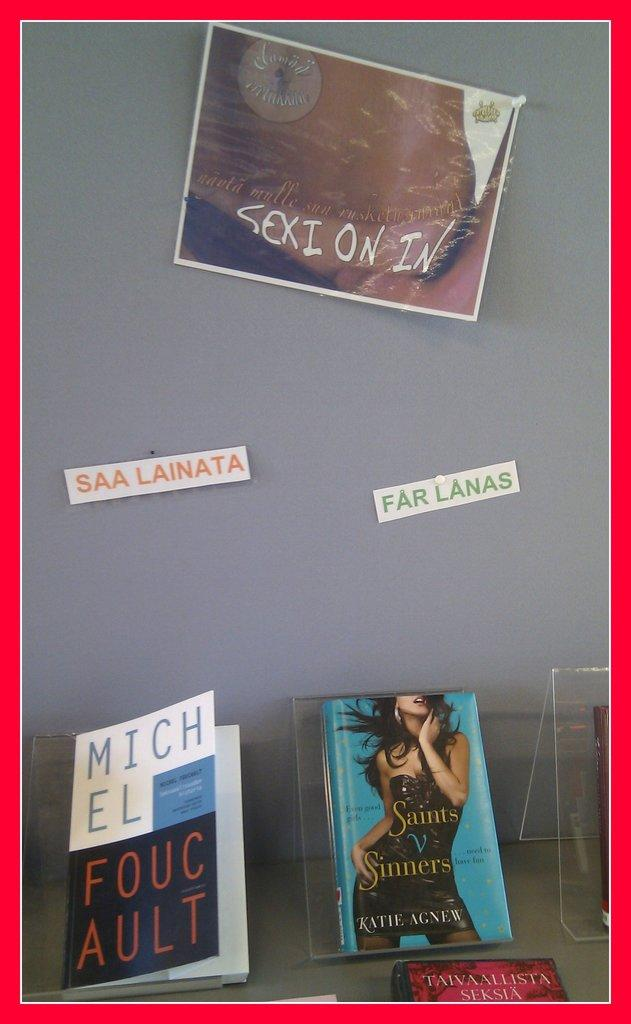<image>
Render a clear and concise summary of the photo. Two books, on e is called Saints v sinners by katie agnew. 